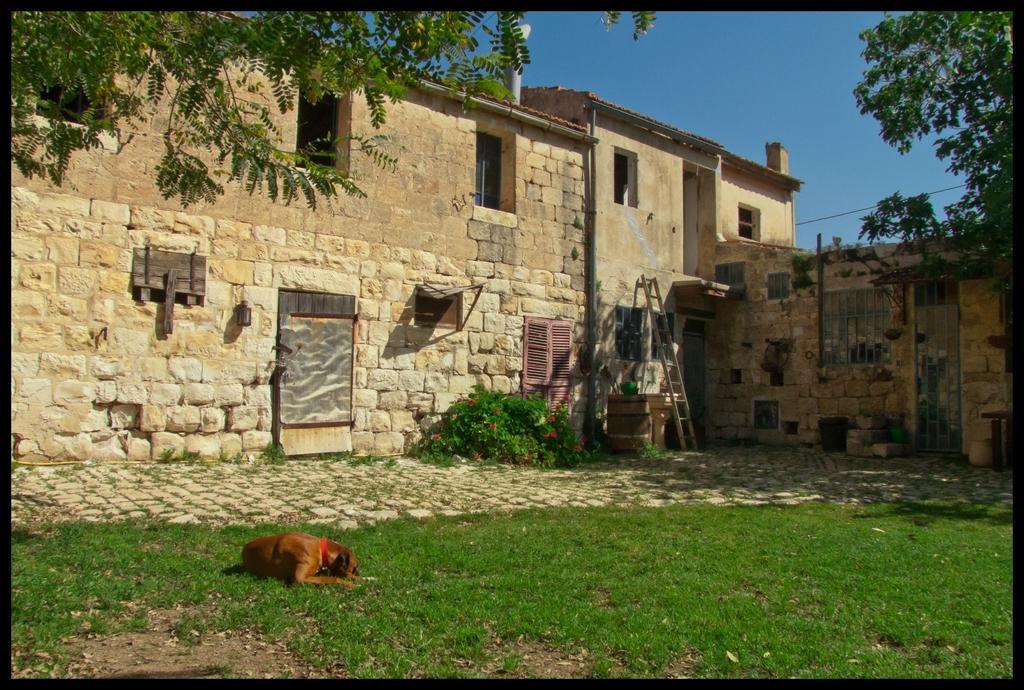Please provide a concise description of this image. In this image we can see buildings, wall, door, windows, dog, grass, trees, plants and sky. 